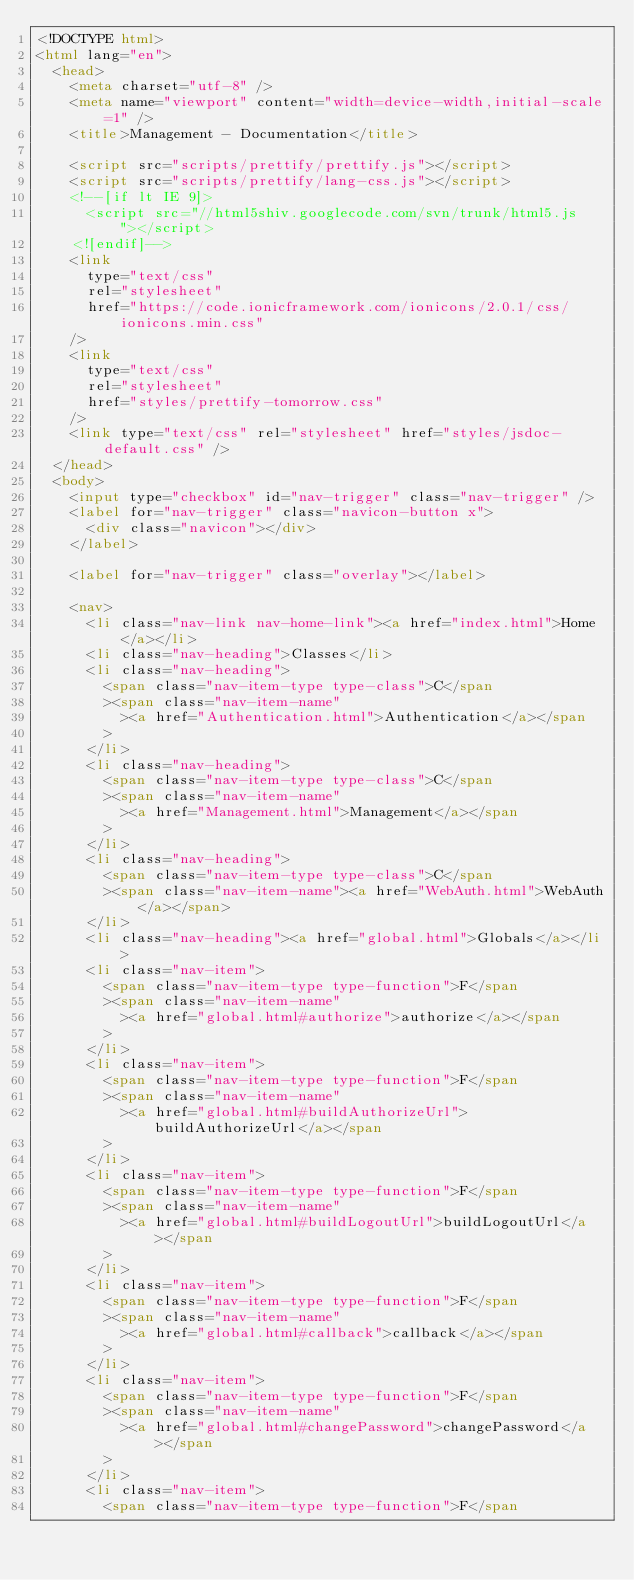Convert code to text. <code><loc_0><loc_0><loc_500><loc_500><_HTML_><!DOCTYPE html>
<html lang="en">
  <head>
    <meta charset="utf-8" />
    <meta name="viewport" content="width=device-width,initial-scale=1" />
    <title>Management - Documentation</title>

    <script src="scripts/prettify/prettify.js"></script>
    <script src="scripts/prettify/lang-css.js"></script>
    <!--[if lt IE 9]>
      <script src="//html5shiv.googlecode.com/svn/trunk/html5.js"></script>
    <![endif]-->
    <link
      type="text/css"
      rel="stylesheet"
      href="https://code.ionicframework.com/ionicons/2.0.1/css/ionicons.min.css"
    />
    <link
      type="text/css"
      rel="stylesheet"
      href="styles/prettify-tomorrow.css"
    />
    <link type="text/css" rel="stylesheet" href="styles/jsdoc-default.css" />
  </head>
  <body>
    <input type="checkbox" id="nav-trigger" class="nav-trigger" />
    <label for="nav-trigger" class="navicon-button x">
      <div class="navicon"></div>
    </label>

    <label for="nav-trigger" class="overlay"></label>

    <nav>
      <li class="nav-link nav-home-link"><a href="index.html">Home</a></li>
      <li class="nav-heading">Classes</li>
      <li class="nav-heading">
        <span class="nav-item-type type-class">C</span
        ><span class="nav-item-name"
          ><a href="Authentication.html">Authentication</a></span
        >
      </li>
      <li class="nav-heading">
        <span class="nav-item-type type-class">C</span
        ><span class="nav-item-name"
          ><a href="Management.html">Management</a></span
        >
      </li>
      <li class="nav-heading">
        <span class="nav-item-type type-class">C</span
        ><span class="nav-item-name"><a href="WebAuth.html">WebAuth</a></span>
      </li>
      <li class="nav-heading"><a href="global.html">Globals</a></li>
      <li class="nav-item">
        <span class="nav-item-type type-function">F</span
        ><span class="nav-item-name"
          ><a href="global.html#authorize">authorize</a></span
        >
      </li>
      <li class="nav-item">
        <span class="nav-item-type type-function">F</span
        ><span class="nav-item-name"
          ><a href="global.html#buildAuthorizeUrl">buildAuthorizeUrl</a></span
        >
      </li>
      <li class="nav-item">
        <span class="nav-item-type type-function">F</span
        ><span class="nav-item-name"
          ><a href="global.html#buildLogoutUrl">buildLogoutUrl</a></span
        >
      </li>
      <li class="nav-item">
        <span class="nav-item-type type-function">F</span
        ><span class="nav-item-name"
          ><a href="global.html#callback">callback</a></span
        >
      </li>
      <li class="nav-item">
        <span class="nav-item-type type-function">F</span
        ><span class="nav-item-name"
          ><a href="global.html#changePassword">changePassword</a></span
        >
      </li>
      <li class="nav-item">
        <span class="nav-item-type type-function">F</span</code> 